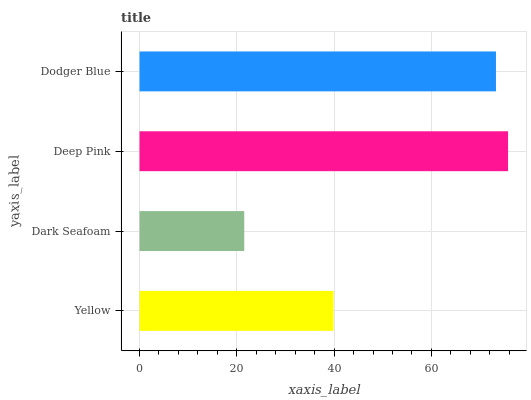Is Dark Seafoam the minimum?
Answer yes or no. Yes. Is Deep Pink the maximum?
Answer yes or no. Yes. Is Deep Pink the minimum?
Answer yes or no. No. Is Dark Seafoam the maximum?
Answer yes or no. No. Is Deep Pink greater than Dark Seafoam?
Answer yes or no. Yes. Is Dark Seafoam less than Deep Pink?
Answer yes or no. Yes. Is Dark Seafoam greater than Deep Pink?
Answer yes or no. No. Is Deep Pink less than Dark Seafoam?
Answer yes or no. No. Is Dodger Blue the high median?
Answer yes or no. Yes. Is Yellow the low median?
Answer yes or no. Yes. Is Deep Pink the high median?
Answer yes or no. No. Is Dark Seafoam the low median?
Answer yes or no. No. 